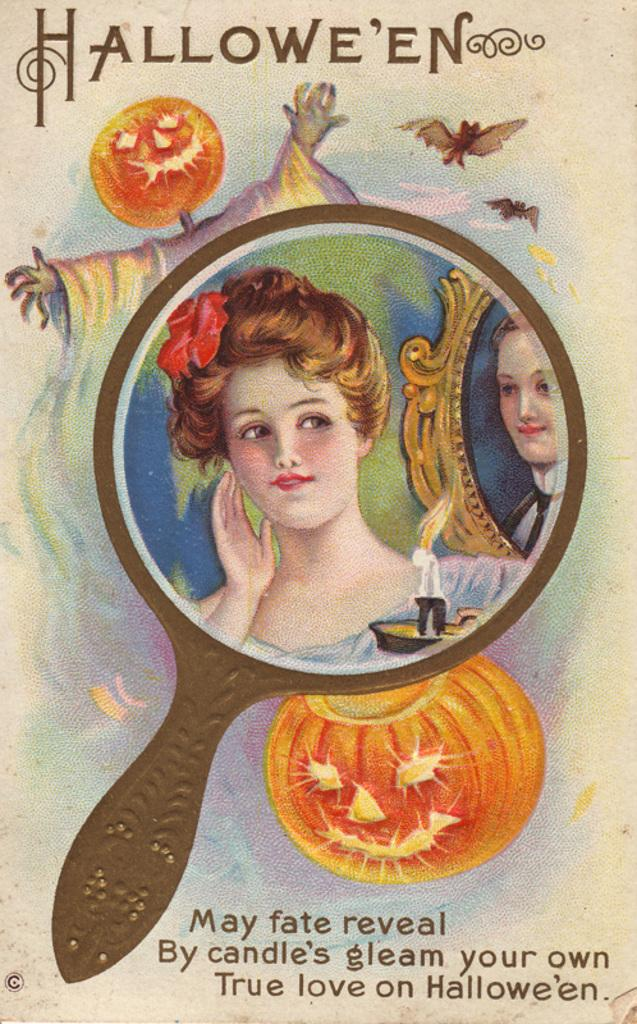What is present on the poster in the image? There is a poster in the image. What can be found on the poster besides images? There are words on the poster. Can you describe the content of the poster? The poster contains both words and images. What type of structure is visible in the stomach of the person in the image? There is no person or stomach visible in the image; it only features a poster with words and images. 